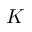Convert formula to latex. <formula><loc_0><loc_0><loc_500><loc_500>K</formula> 